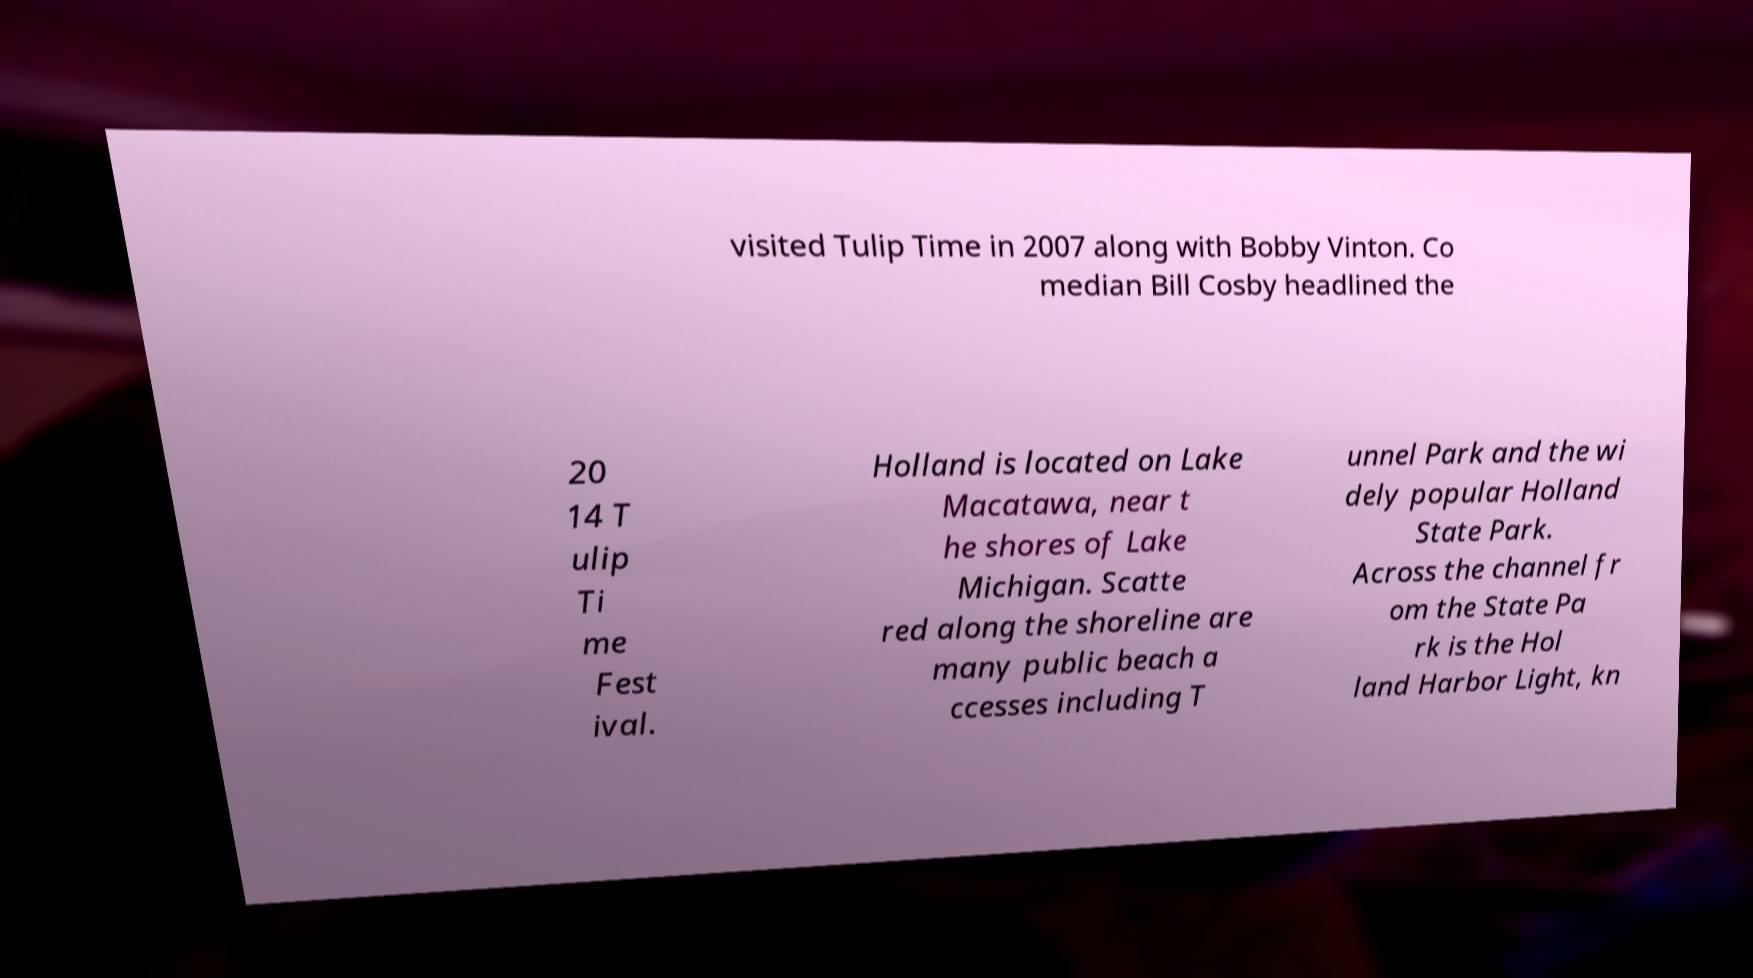Please read and relay the text visible in this image. What does it say? visited Tulip Time in 2007 along with Bobby Vinton. Co median Bill Cosby headlined the 20 14 T ulip Ti me Fest ival. Holland is located on Lake Macatawa, near t he shores of Lake Michigan. Scatte red along the shoreline are many public beach a ccesses including T unnel Park and the wi dely popular Holland State Park. Across the channel fr om the State Pa rk is the Hol land Harbor Light, kn 